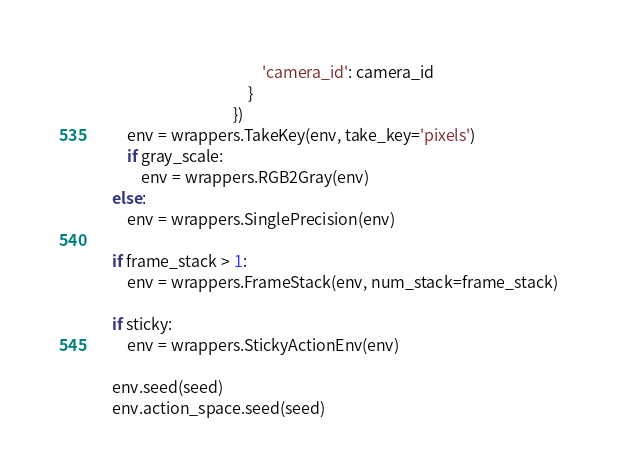Convert code to text. <code><loc_0><loc_0><loc_500><loc_500><_Python_>                                              'camera_id': camera_id
                                          }
                                      })
        env = wrappers.TakeKey(env, take_key='pixels')
        if gray_scale:
            env = wrappers.RGB2Gray(env)
    else:
        env = wrappers.SinglePrecision(env)

    if frame_stack > 1:
        env = wrappers.FrameStack(env, num_stack=frame_stack)

    if sticky:
        env = wrappers.StickyActionEnv(env)

    env.seed(seed)
    env.action_space.seed(seed)</code> 